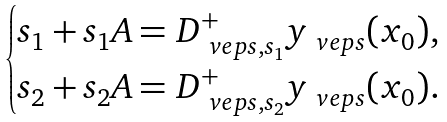<formula> <loc_0><loc_0><loc_500><loc_500>\begin{cases} s _ { 1 } + s _ { 1 } A = D _ { \ v e p s , s _ { 1 } } ^ { + } y _ { \ v e p s } ( x _ { 0 } ) , \\ s _ { 2 } + s _ { 2 } A = D _ { \ v e p s , s _ { 2 } } ^ { + } y _ { \ v e p s } ( x _ { 0 } ) . \end{cases}</formula> 